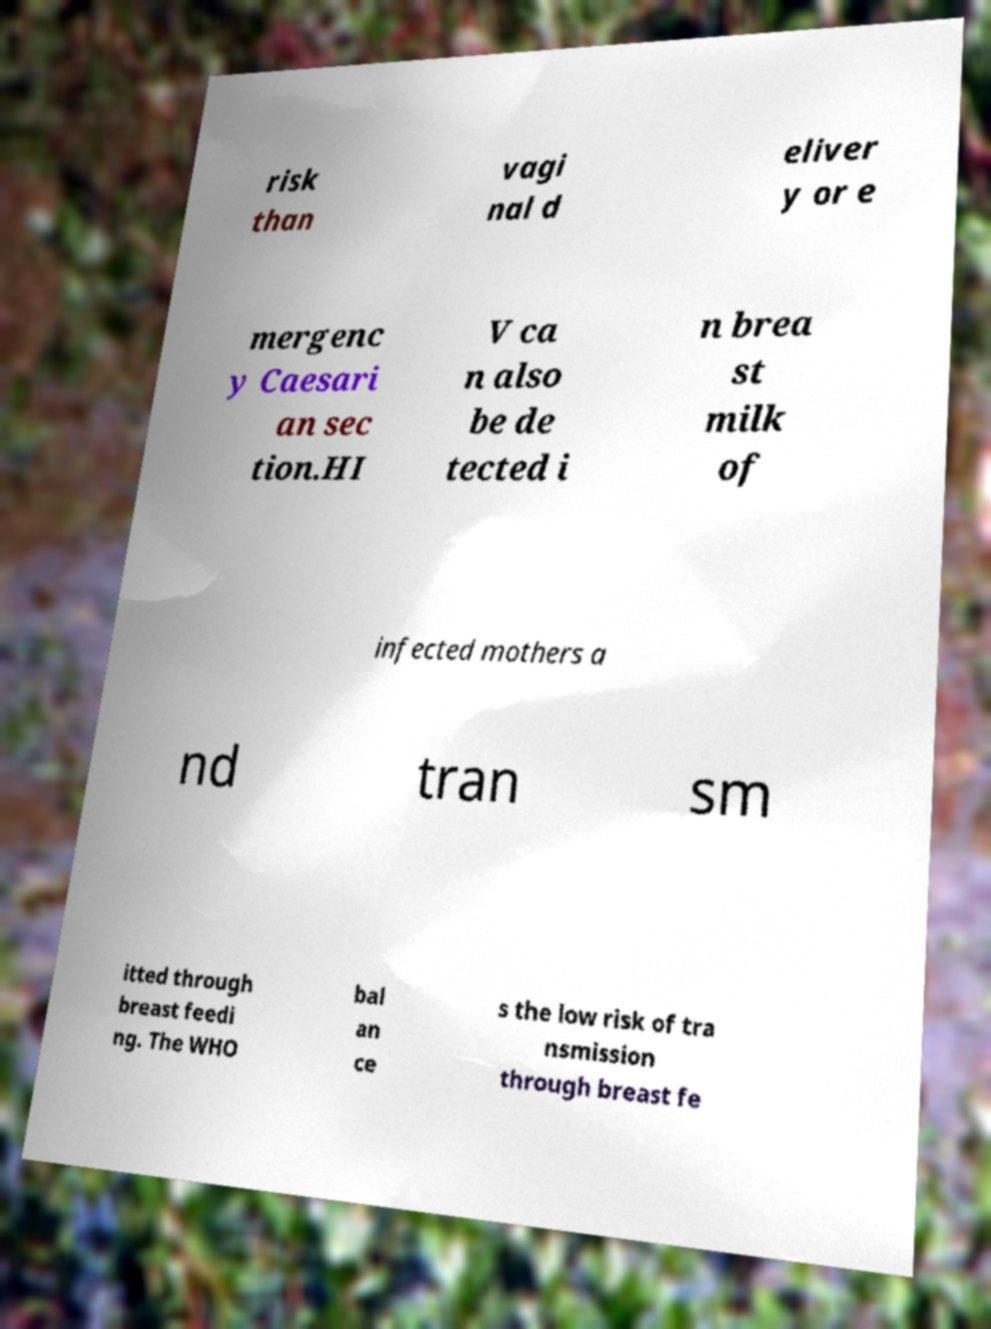There's text embedded in this image that I need extracted. Can you transcribe it verbatim? risk than vagi nal d eliver y or e mergenc y Caesari an sec tion.HI V ca n also be de tected i n brea st milk of infected mothers a nd tran sm itted through breast feedi ng. The WHO bal an ce s the low risk of tra nsmission through breast fe 